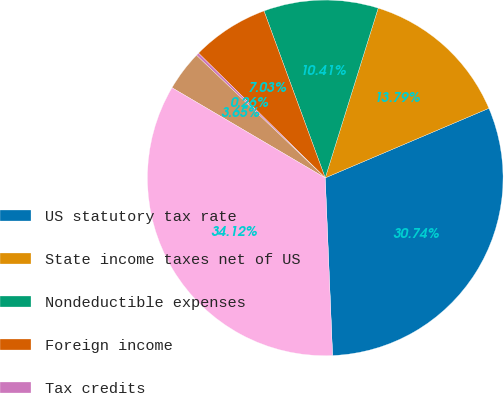Convert chart. <chart><loc_0><loc_0><loc_500><loc_500><pie_chart><fcel>US statutory tax rate<fcel>State income taxes net of US<fcel>Nondeductible expenses<fcel>Foreign income<fcel>Tax credits<fcel>Other net<fcel>Effective rate<nl><fcel>30.74%<fcel>13.79%<fcel>10.41%<fcel>7.03%<fcel>0.26%<fcel>3.65%<fcel>34.12%<nl></chart> 